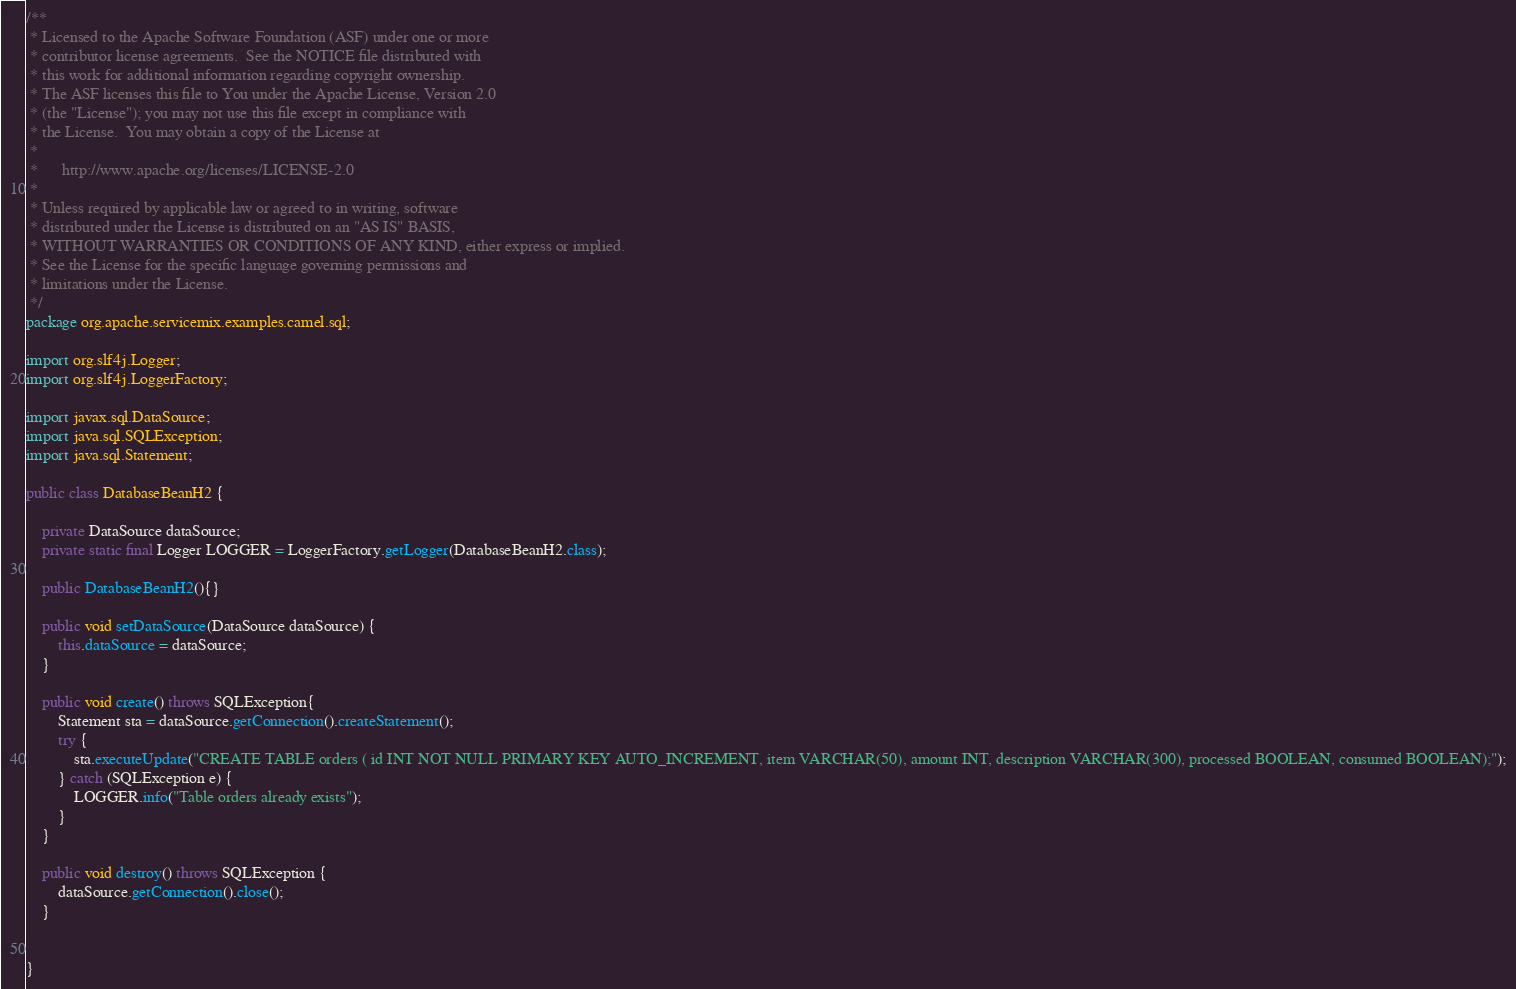<code> <loc_0><loc_0><loc_500><loc_500><_Java_>/**
 * Licensed to the Apache Software Foundation (ASF) under one or more
 * contributor license agreements.  See the NOTICE file distributed with
 * this work for additional information regarding copyright ownership.
 * The ASF licenses this file to You under the Apache License, Version 2.0
 * (the "License"); you may not use this file except in compliance with
 * the License.  You may obtain a copy of the License at
 *
 *      http://www.apache.org/licenses/LICENSE-2.0
 *
 * Unless required by applicable law or agreed to in writing, software
 * distributed under the License is distributed on an "AS IS" BASIS,
 * WITHOUT WARRANTIES OR CONDITIONS OF ANY KIND, either express or implied.
 * See the License for the specific language governing permissions and
 * limitations under the License.
 */
package org.apache.servicemix.examples.camel.sql;

import org.slf4j.Logger;
import org.slf4j.LoggerFactory;

import javax.sql.DataSource;
import java.sql.SQLException;
import java.sql.Statement;

public class DatabaseBeanH2 {

    private DataSource dataSource;
    private static final Logger LOGGER = LoggerFactory.getLogger(DatabaseBeanH2.class);

    public DatabaseBeanH2(){}

    public void setDataSource(DataSource dataSource) {
        this.dataSource = dataSource;
    }

    public void create() throws SQLException{
        Statement sta = dataSource.getConnection().createStatement();
        try {
            sta.executeUpdate("CREATE TABLE orders ( id INT NOT NULL PRIMARY KEY AUTO_INCREMENT, item VARCHAR(50), amount INT, description VARCHAR(300), processed BOOLEAN, consumed BOOLEAN);");
        } catch (SQLException e) {
            LOGGER.info("Table orders already exists");
        }
    }

    public void destroy() throws SQLException {
        dataSource.getConnection().close();
    }


}
</code> 